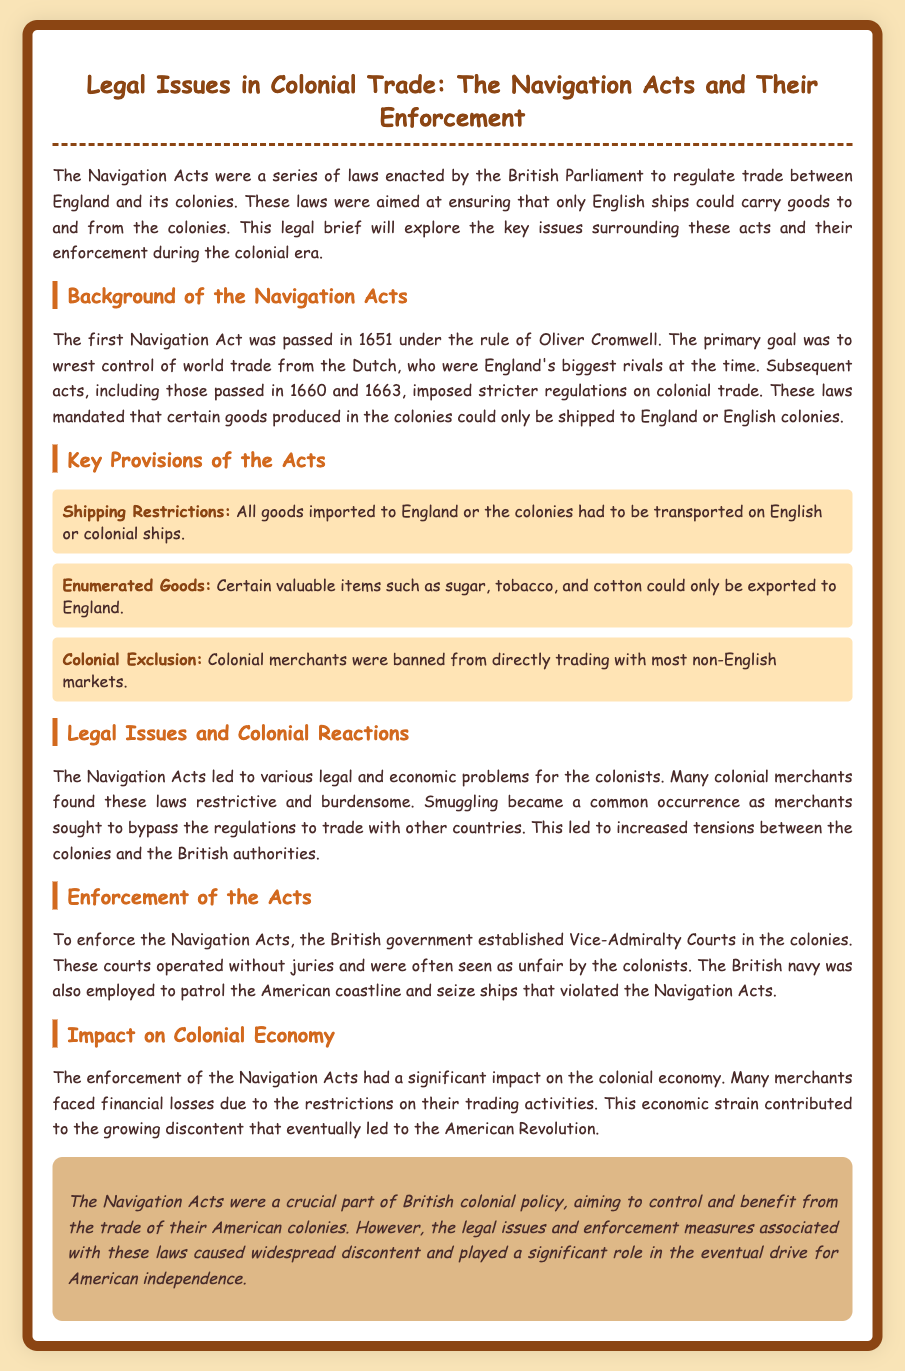What year was the first Navigation Act passed? The document states that the first Navigation Act was passed in 1651.
Answer: 1651 Who passed the first Navigation Act? According to the document, the first Navigation Act was passed under the rule of Oliver Cromwell.
Answer: Oliver Cromwell What was one of the key provisions related to shipping? The document mentions that all goods imported to England or the colonies had to be transported on English or colonial ships.
Answer: English or colonial ships What items were considered enumerated goods? The legal brief lists sugar, tobacco, and cotton as certain valuable items that could only be exported to England.
Answer: sugar, tobacco, and cotton What was a common response by colonial merchants to the Navigation Acts? The document describes that smuggling became a common occurrence as merchants sought to bypass the regulations.
Answer: smuggling What type of courts were established to enforce the Navigation Acts? The document states that Vice-Admiralty Courts were established in the colonies to enforce the Navigation Acts.
Answer: Vice-Admiralty Courts What impact did the Navigation Acts have on colonial merchants? The brief mentions that many merchants faced financial losses due to the restrictions on their trading activities.
Answer: financial losses What role did the British navy play regarding the Navigation Acts? According to the document, the British navy was employed to patrol the American coastline and seize ships that violated the Navigation Acts.
Answer: seize ships What was a significant outcome of the enforcement of the Navigation Acts? The document indicates that the enforcement contributed to growing discontent that eventually led to the American Revolution.
Answer: American Revolution 